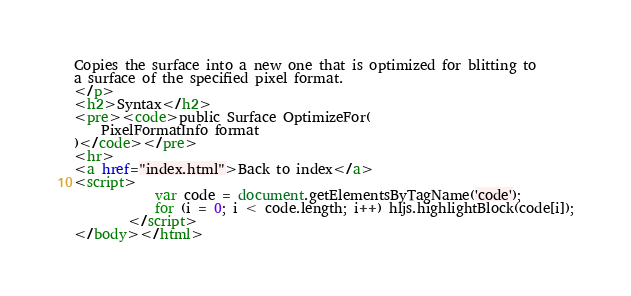Convert code to text. <code><loc_0><loc_0><loc_500><loc_500><_HTML_>Copies the surface into a new one that is optimized for blitting to
a surface of the specified pixel format.
</p>
<h2>Syntax</h2>
<pre><code>public Surface OptimizeFor(
	PixelFormatInfo format
)</code></pre>
<hr>
<a href="index.html">Back to index</a>
<script>
            var code = document.getElementsByTagName('code');
            for (i = 0; i < code.length; i++) hljs.highlightBlock(code[i]);
        </script>
</body></html></code> 